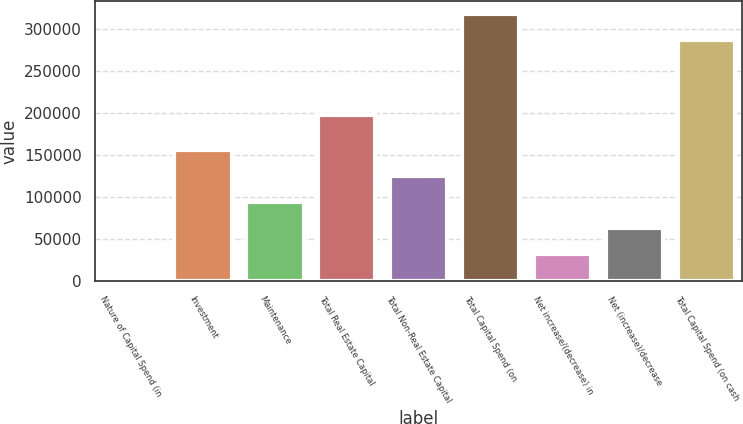Convert chart. <chart><loc_0><loc_0><loc_500><loc_500><bar_chart><fcel>Nature of Capital Spend (in<fcel>Investment<fcel>Maintenance<fcel>Total Real Estate Capital<fcel>Total Non-Real Estate Capital<fcel>Total Capital Spend (on<fcel>Net increase/(decrease) in<fcel>Net (increase)/decrease<fcel>Total Capital Spend (on cash<nl><fcel>2013<fcel>157010<fcel>95011.2<fcel>197571<fcel>126011<fcel>318294<fcel>33012.4<fcel>64011.8<fcel>287295<nl></chart> 